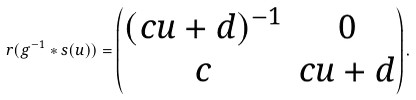Convert formula to latex. <formula><loc_0><loc_0><loc_500><loc_500>r ( g ^ { - 1 } * s ( u ) ) = \begin{pmatrix} ( c u + d ) ^ { - 1 } & 0 \\ c & c u + d \end{pmatrix} .</formula> 